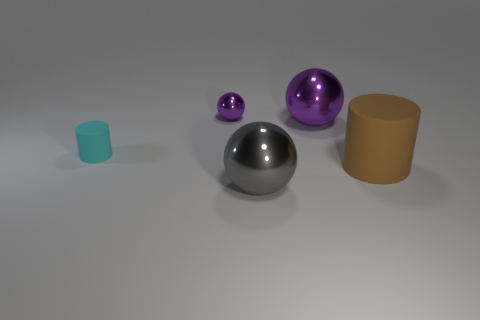Subtract all green spheres. Subtract all red cylinders. How many spheres are left? 3 Add 3 small things. How many objects exist? 8 Subtract all balls. How many objects are left? 2 Add 2 big gray metallic spheres. How many big gray metallic spheres are left? 3 Add 3 large matte things. How many large matte things exist? 4 Subtract 0 red cubes. How many objects are left? 5 Subtract all cyan cylinders. Subtract all cyan objects. How many objects are left? 3 